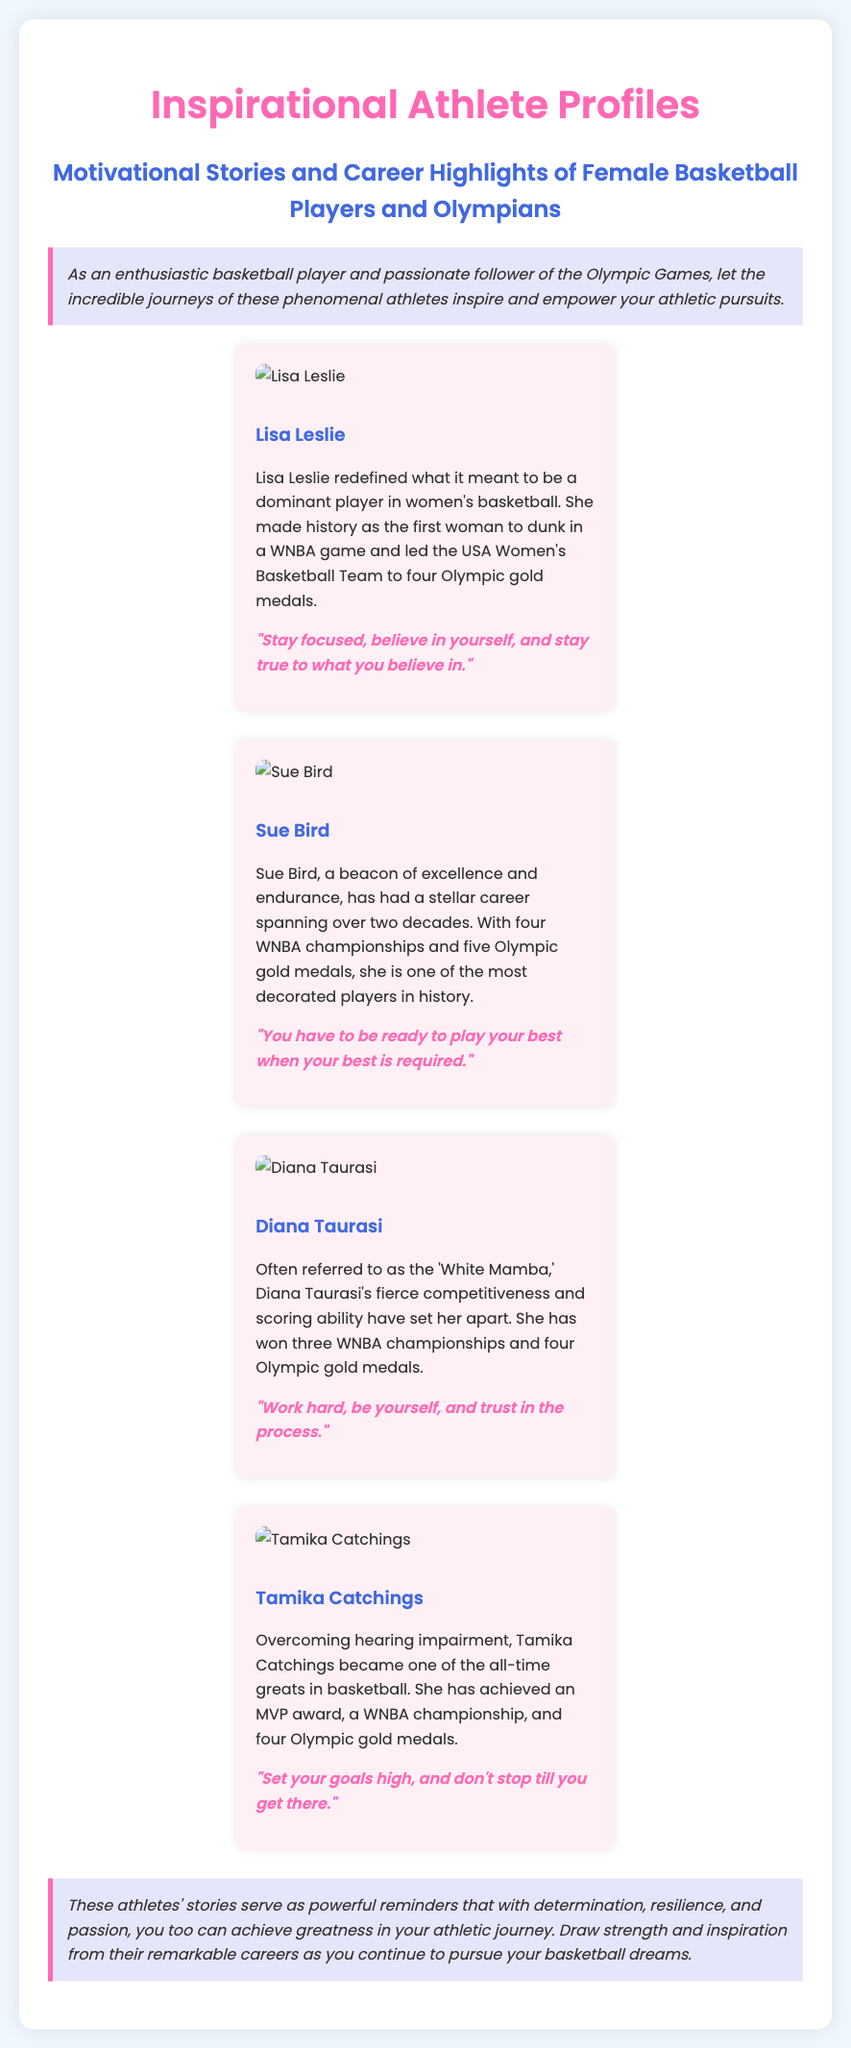What is the title of the document? The title of the document is prominently displayed at the top and is "Inspirational Athlete Profiles."
Answer: Inspirational Athlete Profiles Who is the first athlete featured in the profiles? The first athlete mentioned in the profiles is Lisa Leslie.
Answer: Lisa Leslie How many Olympic gold medals did Sue Bird win? Sue Bird's accomplishments include five Olympic gold medals, as stated in her profile.
Answer: Five What unique achievement did Lisa Leslie accomplish in the WNBA? Lisa Leslie made history as the first woman to achieve a specific feat in the WNBA.
Answer: Dunk What quote is associated with Tamika Catchings? Tamika Catchings' profile includes the quote, "Set your goals high, and don't stop till you get there."
Answer: "Set your goals high, and don't stop till you get there." Which athlete is referred to as the 'White Mamba'? In the document, Diana Taurasi is referred to as the 'White Mamba.'
Answer: Diana Taurasi How many WNBA championships has Diana Taurasi won? Her profile indicates that Diana Taurasi has won three WNBA championships.
Answer: Three What color is used for the document's background? The background color of the document is a light blue shade, specifically mentioned in the style section.
Answer: Light blue What is the main purpose of the profiles in this document? The document aims to inspire and empower readers in their athletic journeys through stories of successful athletes.
Answer: Inspire and empower 